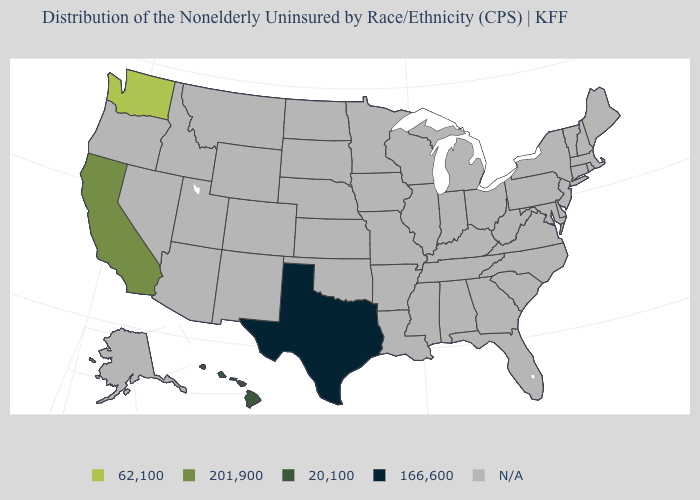Name the states that have a value in the range 201,900?
Quick response, please. California. Name the states that have a value in the range 166,600?
Concise answer only. Texas. Name the states that have a value in the range 201,900?
Quick response, please. California. Name the states that have a value in the range N/A?
Short answer required. Alabama, Alaska, Arizona, Arkansas, Colorado, Connecticut, Delaware, Florida, Georgia, Idaho, Illinois, Indiana, Iowa, Kansas, Kentucky, Louisiana, Maine, Maryland, Massachusetts, Michigan, Minnesota, Mississippi, Missouri, Montana, Nebraska, Nevada, New Hampshire, New Jersey, New Mexico, New York, North Carolina, North Dakota, Ohio, Oklahoma, Oregon, Pennsylvania, Rhode Island, South Carolina, South Dakota, Tennessee, Utah, Vermont, Virginia, West Virginia, Wisconsin, Wyoming. What is the value of South Carolina?
Answer briefly. N/A. What is the value of Maine?
Answer briefly. N/A. Name the states that have a value in the range 20,100?
Concise answer only. Hawaii. Which states have the lowest value in the USA?
Answer briefly. Texas. What is the value of Louisiana?
Write a very short answer. N/A. What is the value of Arizona?
Concise answer only. N/A. Name the states that have a value in the range 201,900?
Write a very short answer. California. What is the value of North Dakota?
Short answer required. N/A. 